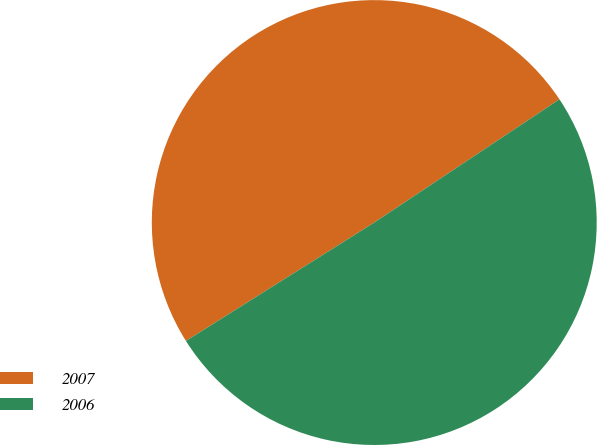Convert chart to OTSL. <chart><loc_0><loc_0><loc_500><loc_500><pie_chart><fcel>2007<fcel>2006<nl><fcel>49.59%<fcel>50.41%<nl></chart> 